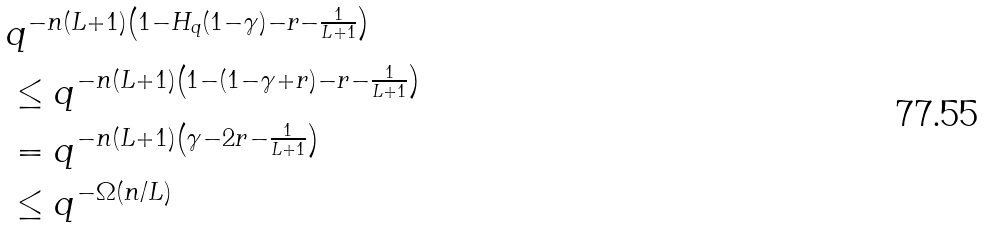<formula> <loc_0><loc_0><loc_500><loc_500>& q ^ { - n ( L + 1 ) \left ( 1 - H _ { q } ( 1 - \gamma ) - r - \frac { 1 } { L + 1 } \right ) } \\ & \leq q ^ { - n ( L + 1 ) \left ( 1 - ( 1 - \gamma + r ) - r - \frac { 1 } { L + 1 } \right ) } \\ & = q ^ { - n ( L + 1 ) \left ( \gamma - 2 r - \frac { 1 } { L + 1 } \right ) } \\ & \leq q ^ { - \Omega ( n / L ) }</formula> 